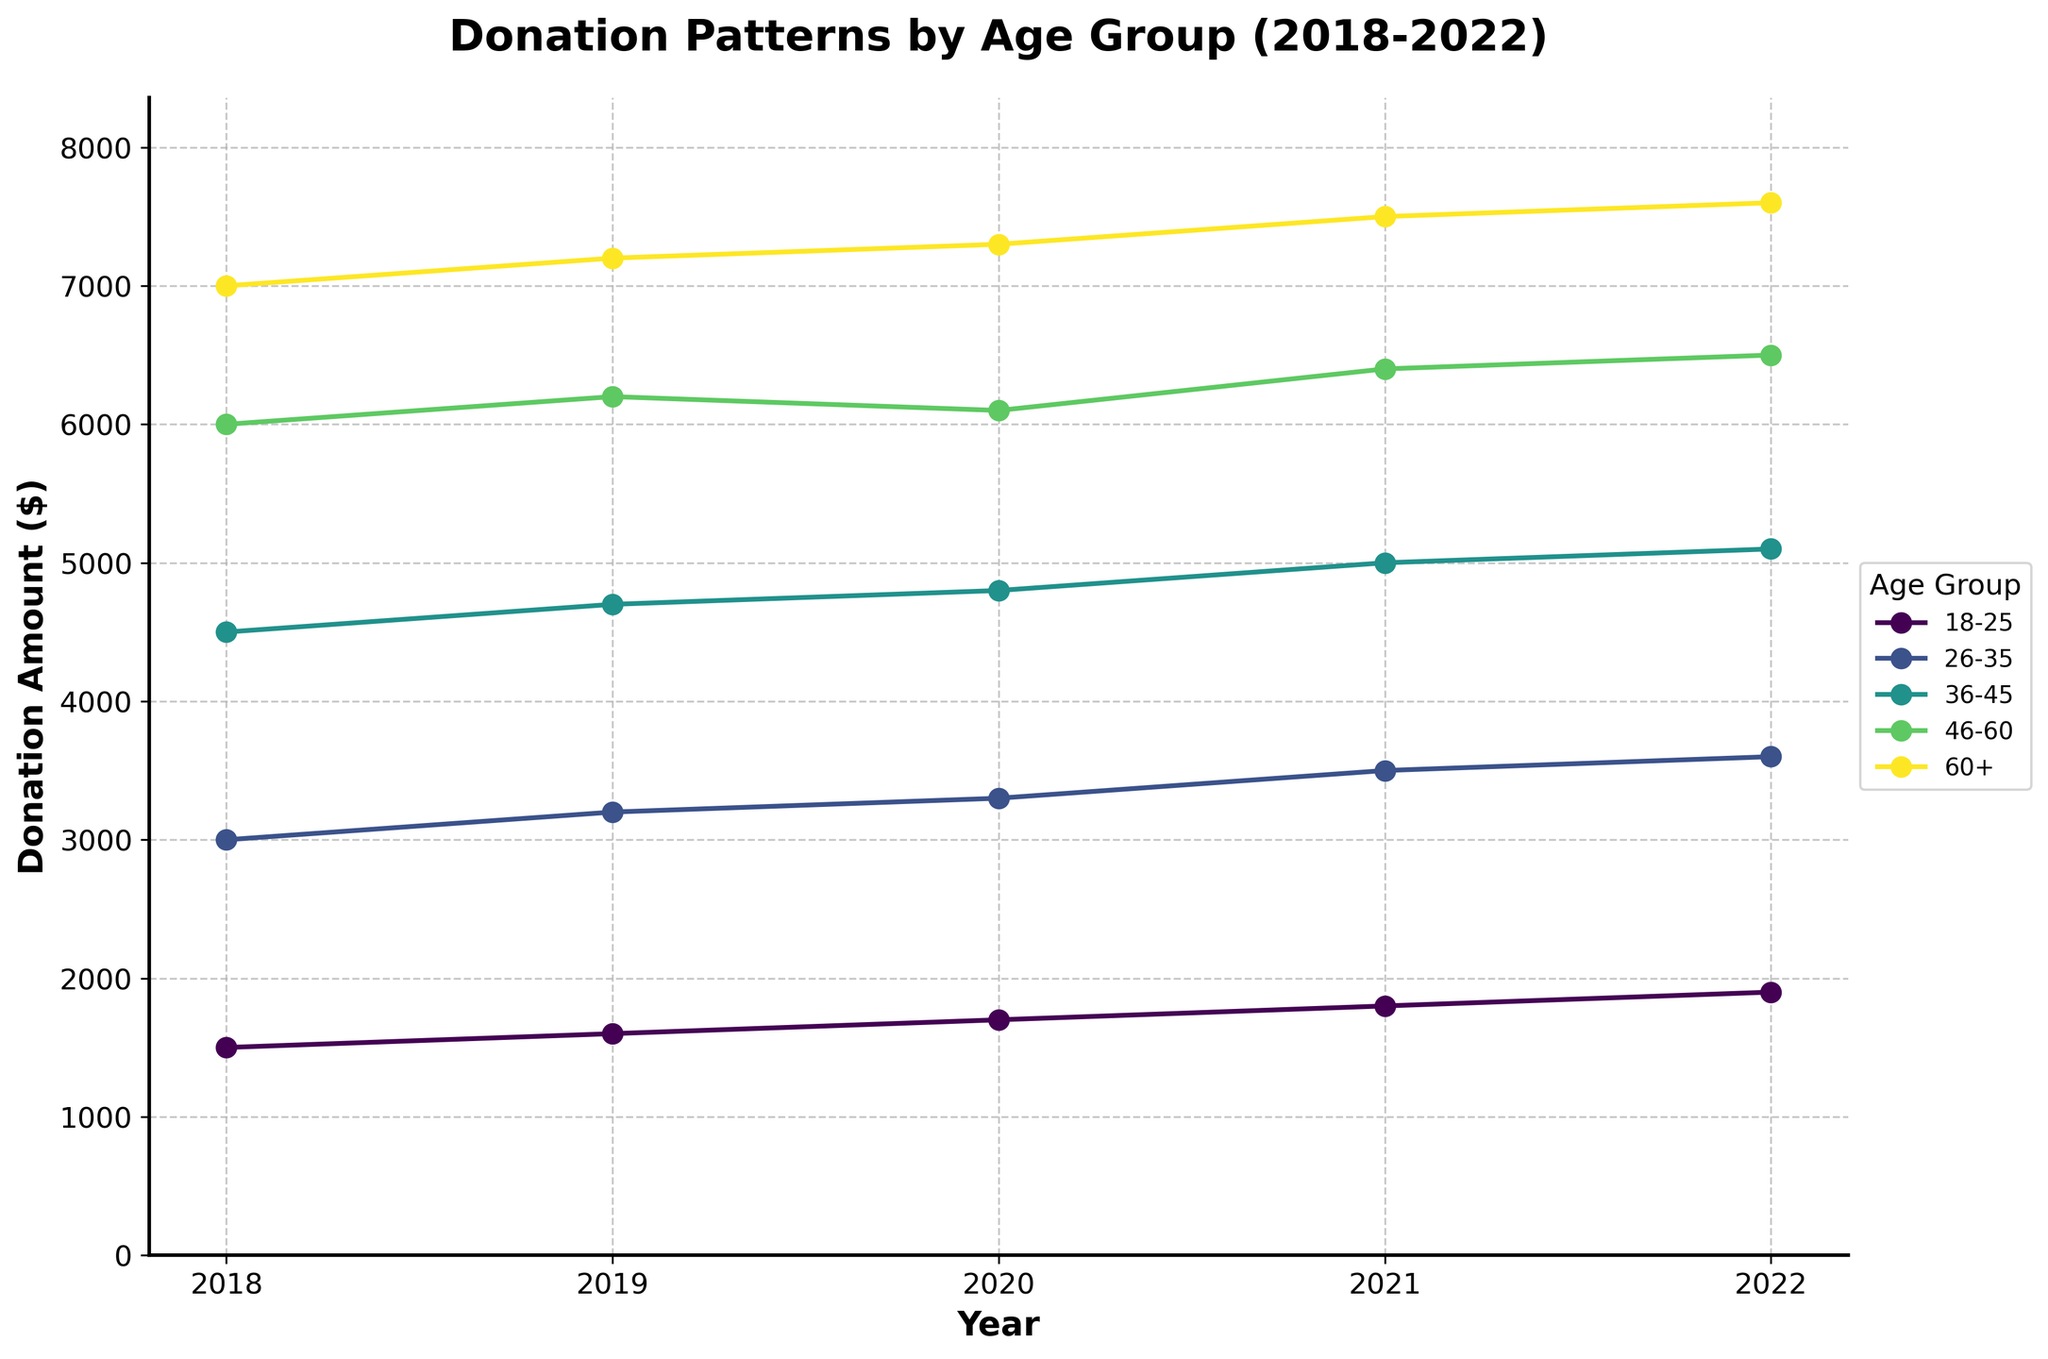What is the title of the plot? The title of the plot is provided at the top. It reads "Donation Patterns by Age Group (2018-2022)"
Answer: Donation Patterns by Age Group (2018-2022) Which age group had the highest donation amount in 2018? By looking at the 2018 values, we find the maximum donation amount is $7000, attributed to the "60+" age group
Answer: 60+ In 2020, which age group's donation amount decreased compared to 2019? By comparing the 2020 and 2019 donation amounts, we find that only the "46-60" age group's donation amount decreased from $6200 in 2019 to $6100 in 2020
Answer: 46-60 What is the total donation amount for all age groups in 2021? To find the total, sum the 2021 donation amounts: $1800 + $3500 + $5000 + $6400 + $7500
Answer: $24200 How many times in the last five years did the "18-25" age group's donation amounts increase compared to the previous year? By examining the "18-25" group's donation amounts: $1500 in 2018, $1600 in 2019, $1700 in 2020, $1800 in 2021, $1900 in 2022, we see an increase each year (4 times)
Answer: 4 times Which age group shows the most stable donation pattern over the years? Evaluating the graph for each age group, the "26-35" age group's donation amounts show a consistent increase without any fluctuations: $3000, $3200, $3300, $3500, $3600
Answer: 26-35 What is the average donation amount of the "36-45" age group over the five years? Sum the "36-45" donation amounts over five years: $4500 + $4700 + $4800 + $5000 + $5100, then divide by 5: $24100 / 5
Answer: $4820 Which age group had the smallest donation increase from 2021 to 2022? Comparing the differences between 2021 and 2022 for all age groups, the smallest increase is in the "60+" age group with an increase from $7500 to $7600
Answer: 60+ In 2019, how much more did the "60+" age group donate compared to the "18-25" age group? Subtract the "18-25" group's 2019 donation amount from the "60+" group's 2019 donation amount: $7200 - $1600
Answer: $5600 Which age group had the highest donation growth from 2018 to 2022? Calculate the difference between 2022 and 2018 for each age group. The "18-25" age group had the most significant growth: $1900 - $1500 = $400
Answer: 18-25 